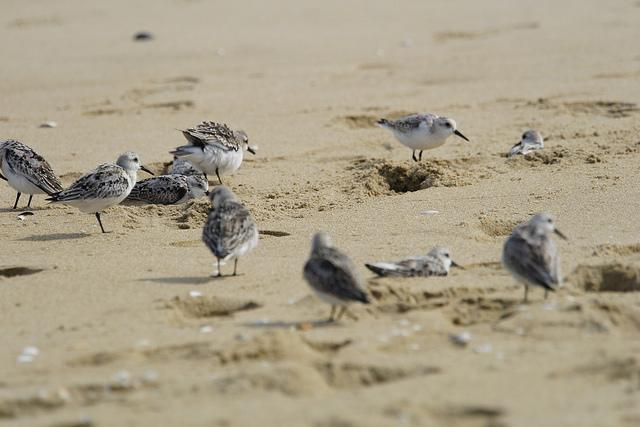What do people usually feed these animals? Please explain your reasoning. bread. It shows the type  of breeds of the bird. 